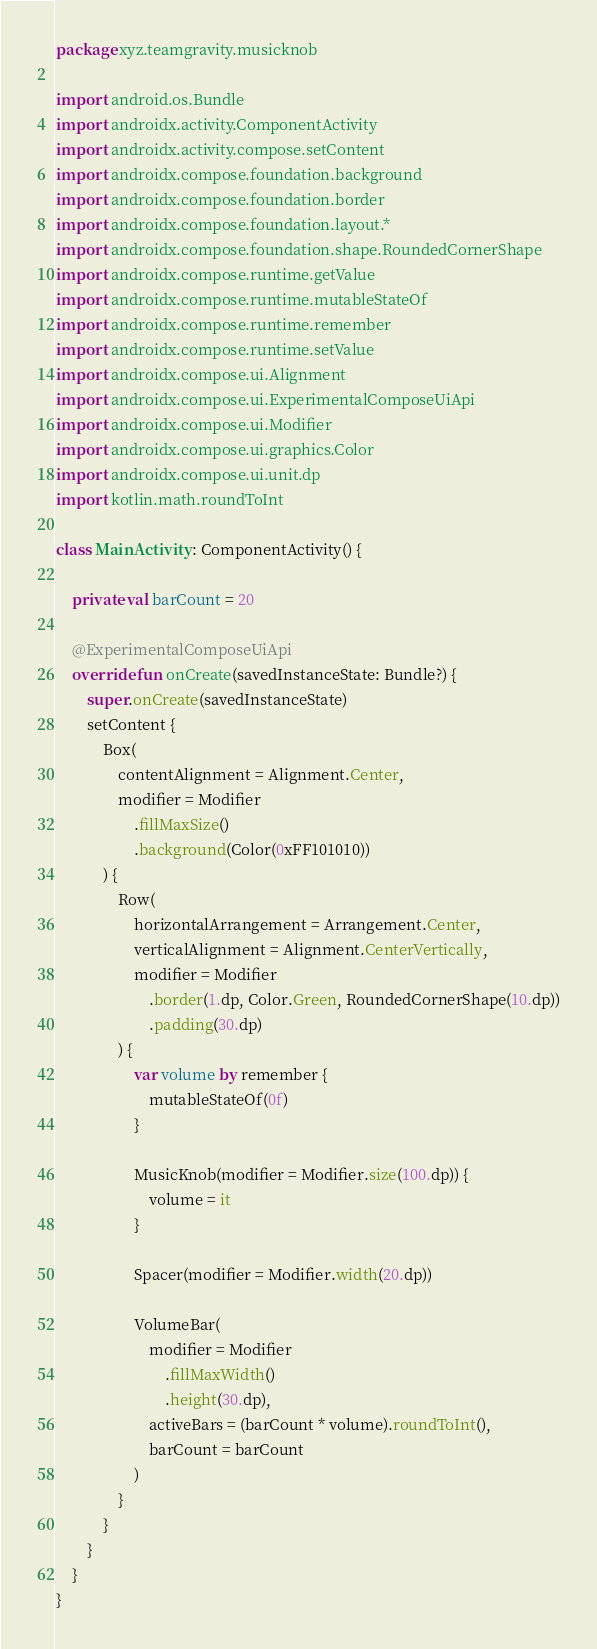<code> <loc_0><loc_0><loc_500><loc_500><_Kotlin_>package xyz.teamgravity.musicknob

import android.os.Bundle
import androidx.activity.ComponentActivity
import androidx.activity.compose.setContent
import androidx.compose.foundation.background
import androidx.compose.foundation.border
import androidx.compose.foundation.layout.*
import androidx.compose.foundation.shape.RoundedCornerShape
import androidx.compose.runtime.getValue
import androidx.compose.runtime.mutableStateOf
import androidx.compose.runtime.remember
import androidx.compose.runtime.setValue
import androidx.compose.ui.Alignment
import androidx.compose.ui.ExperimentalComposeUiApi
import androidx.compose.ui.Modifier
import androidx.compose.ui.graphics.Color
import androidx.compose.ui.unit.dp
import kotlin.math.roundToInt

class MainActivity : ComponentActivity() {

    private val barCount = 20

    @ExperimentalComposeUiApi
    override fun onCreate(savedInstanceState: Bundle?) {
        super.onCreate(savedInstanceState)
        setContent {
            Box(
                contentAlignment = Alignment.Center,
                modifier = Modifier
                    .fillMaxSize()
                    .background(Color(0xFF101010))
            ) {
                Row(
                    horizontalArrangement = Arrangement.Center,
                    verticalAlignment = Alignment.CenterVertically,
                    modifier = Modifier
                        .border(1.dp, Color.Green, RoundedCornerShape(10.dp))
                        .padding(30.dp)
                ) {
                    var volume by remember {
                        mutableStateOf(0f)
                    }

                    MusicKnob(modifier = Modifier.size(100.dp)) {
                        volume = it
                    }

                    Spacer(modifier = Modifier.width(20.dp))

                    VolumeBar(
                        modifier = Modifier
                            .fillMaxWidth()
                            .height(30.dp),
                        activeBars = (barCount * volume).roundToInt(),
                        barCount = barCount
                    )
                }
            }
        }
    }
}</code> 